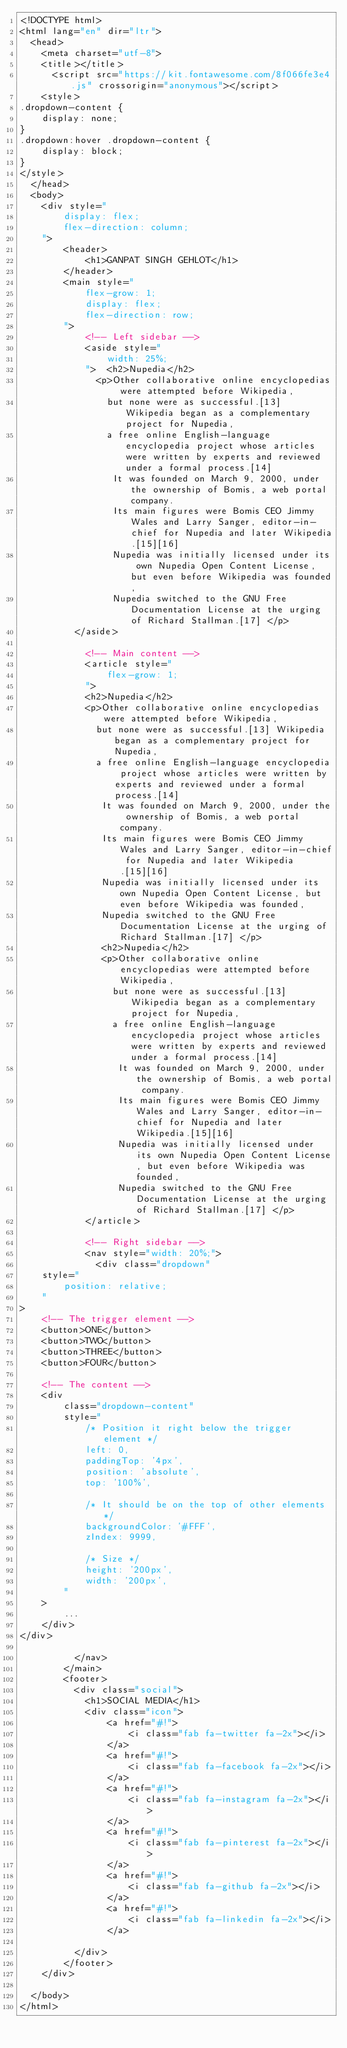Convert code to text. <code><loc_0><loc_0><loc_500><loc_500><_HTML_><!DOCTYPE html>
<html lang="en" dir="ltr">
  <head>
    <meta charset="utf-8">
    <title></title>
      <script src="https://kit.fontawesome.com/8f066fe3e4.js" crossorigin="anonymous"></script>
    <style>
.dropdown-content {
    display: none;
}
.dropdown:hover .dropdown-content {
    display: block;
}
</style>
  </head>
  <body>
    <div style="
        display: flex;
        flex-direction: column;
    ">
        <header>
            <h1>GANPAT SINGH GEHLOT</h1>
        </header>
        <main style="
            flex-grow: 1;
            display: flex;
            flex-direction: row;
        ">
            <!-- Left sidebar -->
            <aside style="
                width: 25%;
            ">  <h2>Nupedia</h2>
              <p>Other collaborative online encyclopedias were attempted before Wikipedia,
                but none were as successful.[13] Wikipedia began as a complementary project for Nupedia,
                a free online English-language encyclopedia project whose articles were written by experts and reviewed under a formal process.[14]
                 It was founded on March 9, 2000, under the ownership of Bomis, a web portal company.
                 Its main figures were Bomis CEO Jimmy Wales and Larry Sanger, editor-in-chief for Nupedia and later Wikipedia.[15][16]
                 Nupedia was initially licensed under its own Nupedia Open Content License, but even before Wikipedia was founded,
                 Nupedia switched to the GNU Free Documentation License at the urging of Richard Stallman.[17] </p>
          </aside>

            <!-- Main content -->
            <article style="
                flex-grow: 1;
            ">
            <h2>Nupedia</h2>
            <p>Other collaborative online encyclopedias were attempted before Wikipedia,
              but none were as successful.[13] Wikipedia began as a complementary project for Nupedia,
              a free online English-language encyclopedia project whose articles were written by experts and reviewed under a formal process.[14]
               It was founded on March 9, 2000, under the ownership of Bomis, a web portal company.
               Its main figures were Bomis CEO Jimmy Wales and Larry Sanger, editor-in-chief for Nupedia and later Wikipedia.[15][16]
               Nupedia was initially licensed under its own Nupedia Open Content License, but even before Wikipedia was founded,
               Nupedia switched to the GNU Free Documentation License at the urging of Richard Stallman.[17] </p>
               <h2>Nupedia</h2>
               <p>Other collaborative online encyclopedias were attempted before Wikipedia,
                 but none were as successful.[13] Wikipedia began as a complementary project for Nupedia,
                 a free online English-language encyclopedia project whose articles were written by experts and reviewed under a formal process.[14]
                  It was founded on March 9, 2000, under the ownership of Bomis, a web portal company.
                  Its main figures were Bomis CEO Jimmy Wales and Larry Sanger, editor-in-chief for Nupedia and later Wikipedia.[15][16]
                  Nupedia was initially licensed under its own Nupedia Open Content License, but even before Wikipedia was founded,
                  Nupedia switched to the GNU Free Documentation License at the urging of Richard Stallman.[17] </p>
            </article>

            <!-- Right sidebar -->
            <nav style="width: 20%;">
              <div class="dropdown"
    style="
        position: relative;
    "
>
    <!-- The trigger element -->
    <button>ONE</button>
    <button>TWO</button>
    <button>THREE</button>
    <button>FOUR</button>

    <!-- The content -->
    <div
        class="dropdown-content"
        style="
            /* Position it right below the trigger element */
            left: 0,
            paddingTop: '4px',
            position: 'absolute',
            top: '100%',

            /* It should be on the top of other elements */
            backgroundColor: '#FFF',
            zIndex: 9999,

            /* Size */
            height: '200px',
            width: '200px',
        "
    >
        ...
    </div>
</div>

          </nav>
        </main>
        <footer>
          <div class="social">
            <h1>SOCIAL MEDIA</h1>
            <div class="icon">
                <a href="#!">
                    <i class="fab fa-twitter fa-2x"></i>
                </a>
                <a href="#!">
                    <i class="fab fa-facebook fa-2x"></i>
                </a>
                <a href="#!">
                    <i class="fab fa-instagram fa-2x"></i>
                </a>
                <a href="#!">
                    <i class="fab fa-pinterest fa-2x"></i>
                </a>
                <a href="#!">
                    <i class="fab fa-github fa-2x"></i>
                </a>
                <a href="#!">
                    <i class="fab fa-linkedin fa-2x"></i>
                </a>

          </div>
        </footer>
    </div>

  </body>
</html>
</code> 